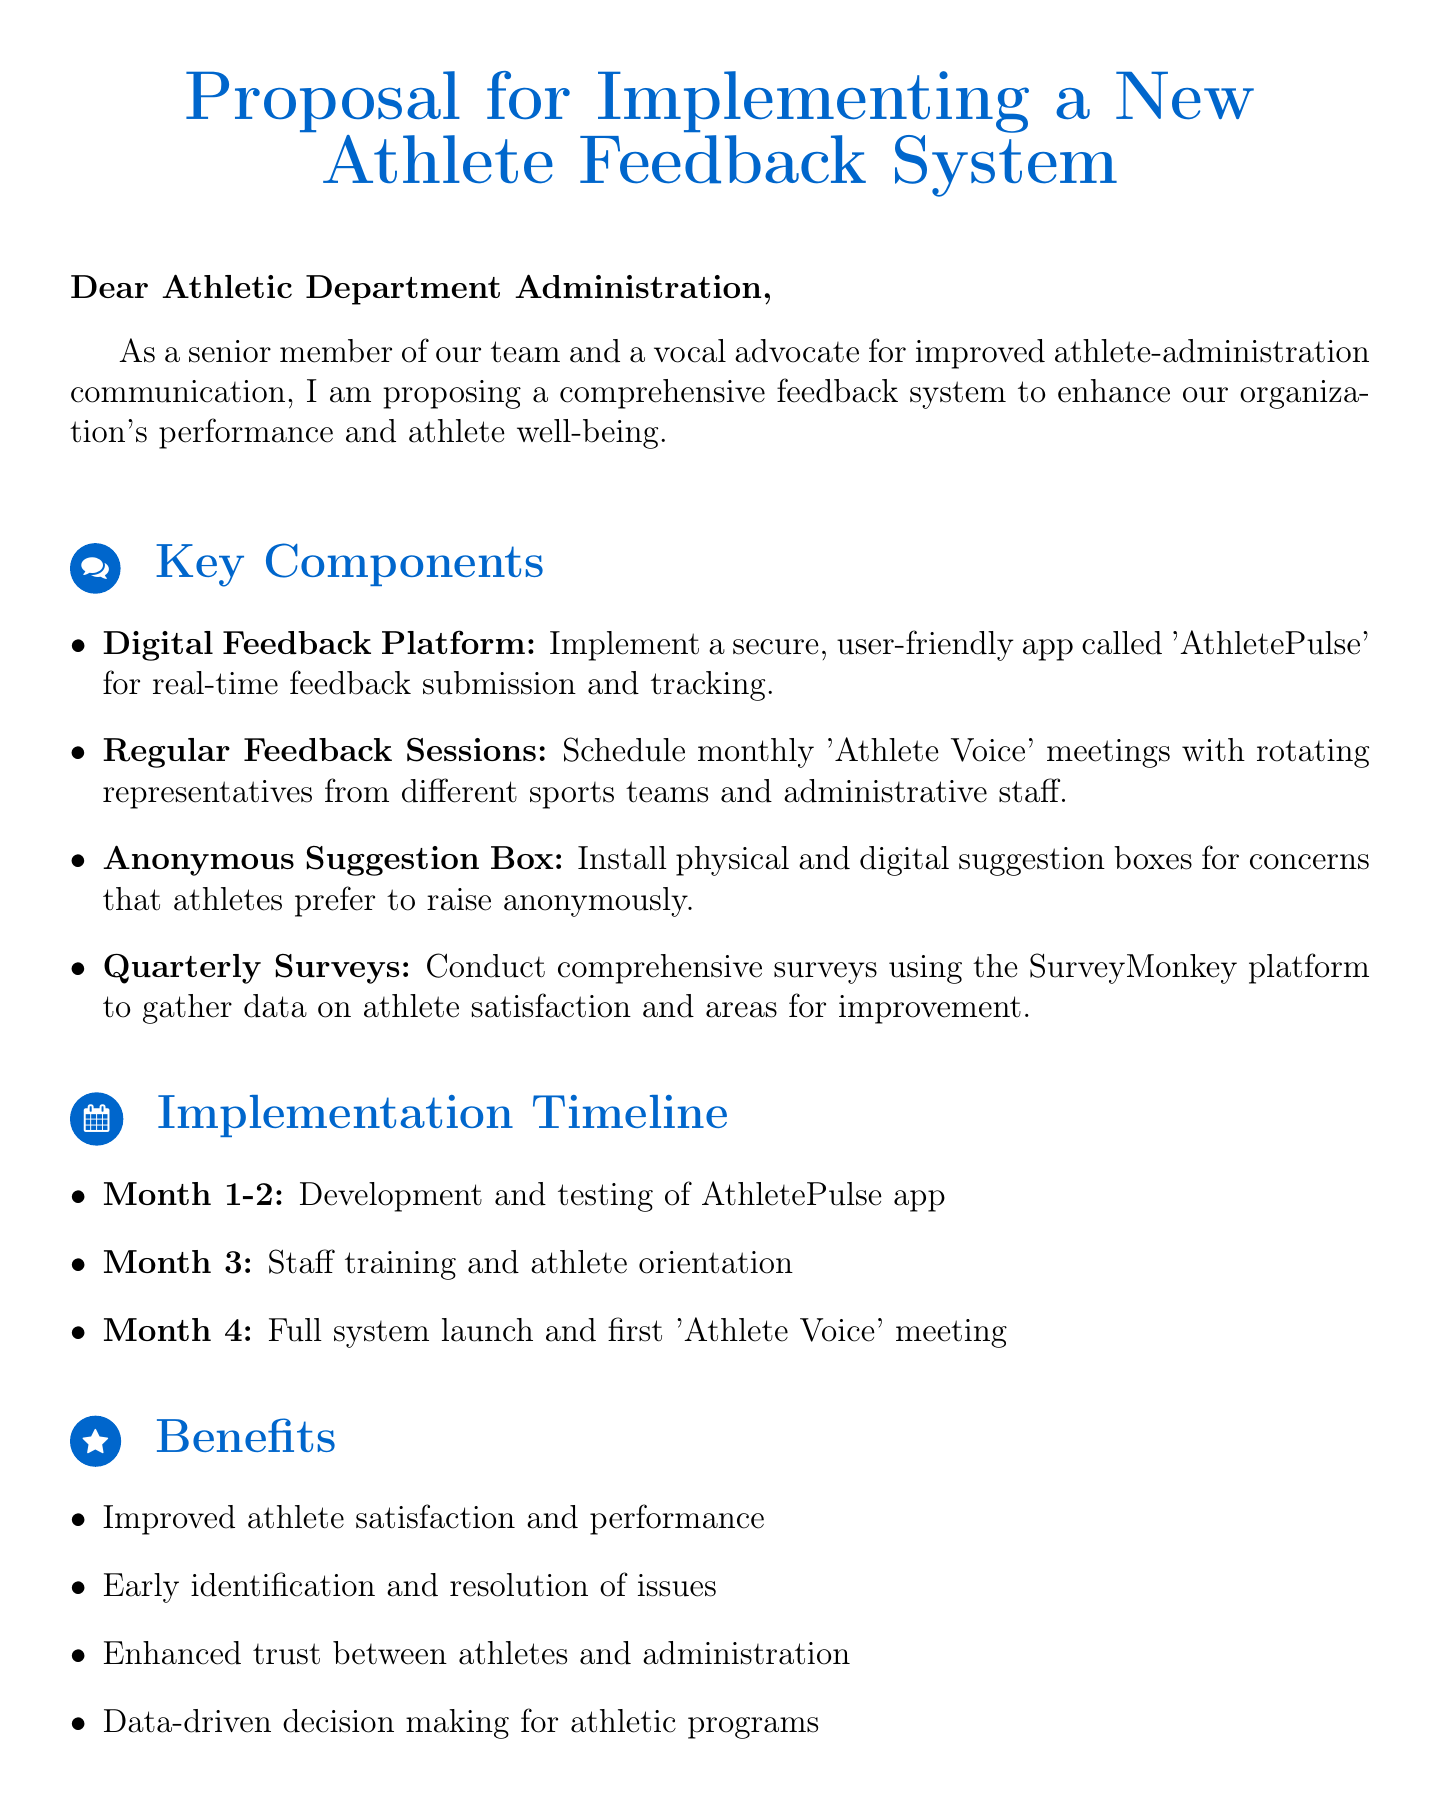What is the main subject of the proposal? The main subject is concerned with implementing a new feedback system for athletes within the organization.
Answer: Proposal for Implementing a New Athlete Feedback System Who is the email addressed to? The email is directed specifically towards the administration of the athletic department.
Answer: Athletic Department Administration What is the first key component mentioned? The first key component discussed in the proposal outlines a specific tool for feedback collection.
Answer: Digital Feedback Platform How long is the development and testing phase for the app? The timeline for the development and testing phase of the app is clearly defined in the implementation stage.
Answer: Month 1-2 What platform will be used for quarterly surveys? The document specifies a widely-used platform for gathering survey data.
Answer: SurveyMonkey List one of the expected benefits of the new feedback system. This question calls for identifying the advantages described in the proposal related to athlete satisfaction.
Answer: Improved athlete satisfaction and performance What type of meetings will be scheduled regularly? The document describes a specific format for sharing athlete feedback among representatives and administration.
Answer: 'Athlete Voice' meetings What will be installed for anonymous feedback? One of the components addresses a method for athletes to provide feedback without revealing their identity.
Answer: Anonymous Suggestion Box What is the proposed final step in the implementation timeline? The proposed timeline outlines the last major event in the early rollout of the new feedback system.
Answer: first 'Athlete Voice' meeting 